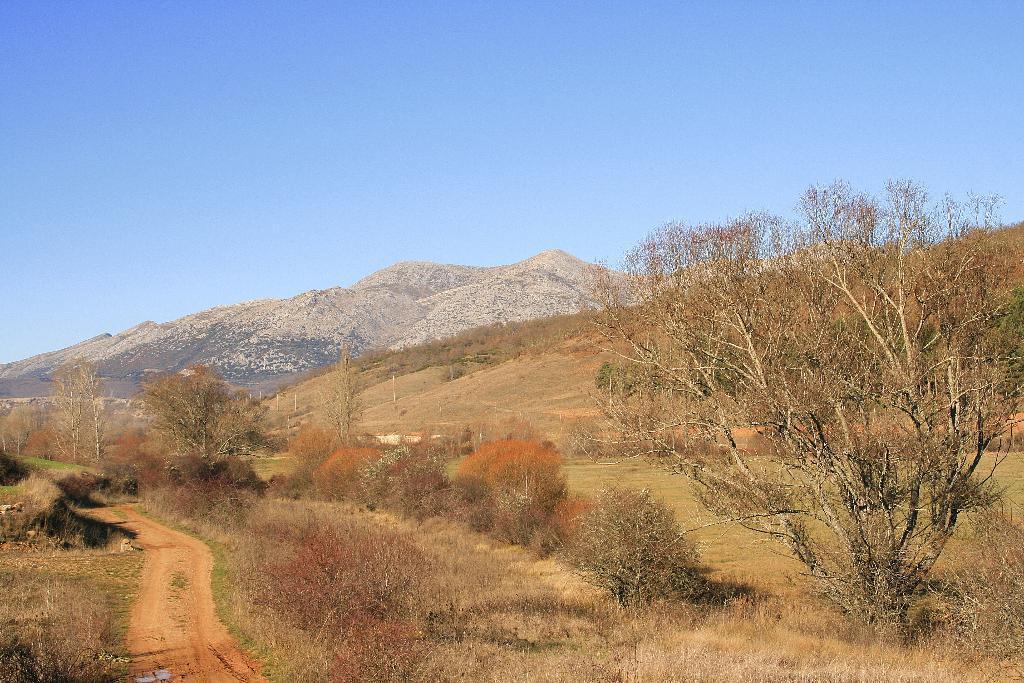Describe this image in one or two sentences. In this image we can see road, trees, plants, grass, hills, poles and sky. 